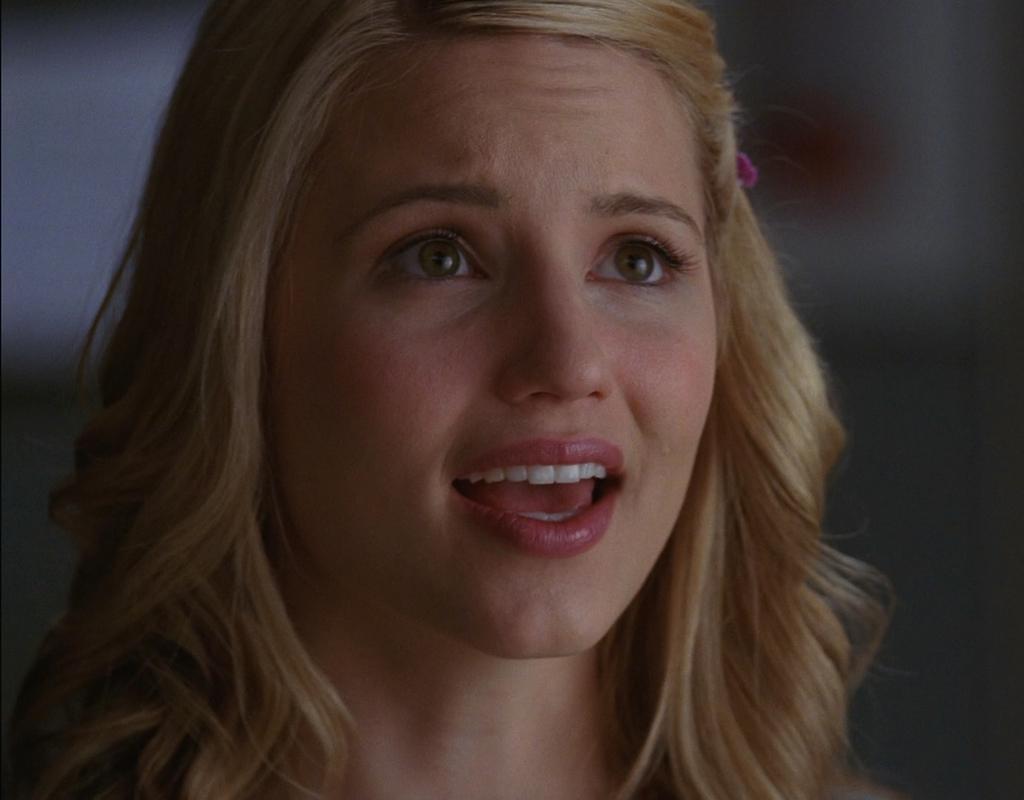Can you describe this image briefly? In this image we can see a girl's face. 